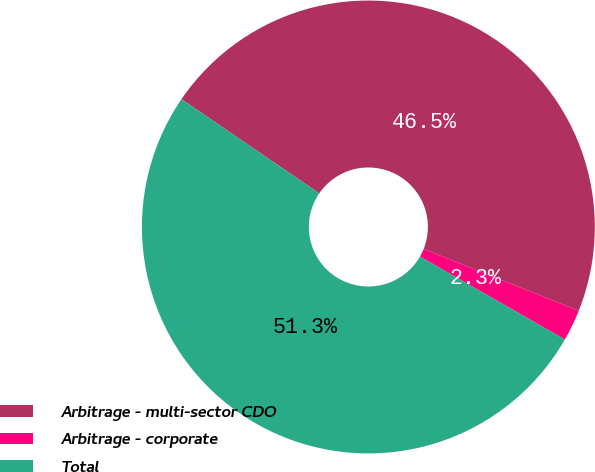Convert chart. <chart><loc_0><loc_0><loc_500><loc_500><pie_chart><fcel>Arbitrage - multi-sector CDO<fcel>Arbitrage - corporate<fcel>Total<nl><fcel>46.48%<fcel>2.25%<fcel>51.26%<nl></chart> 